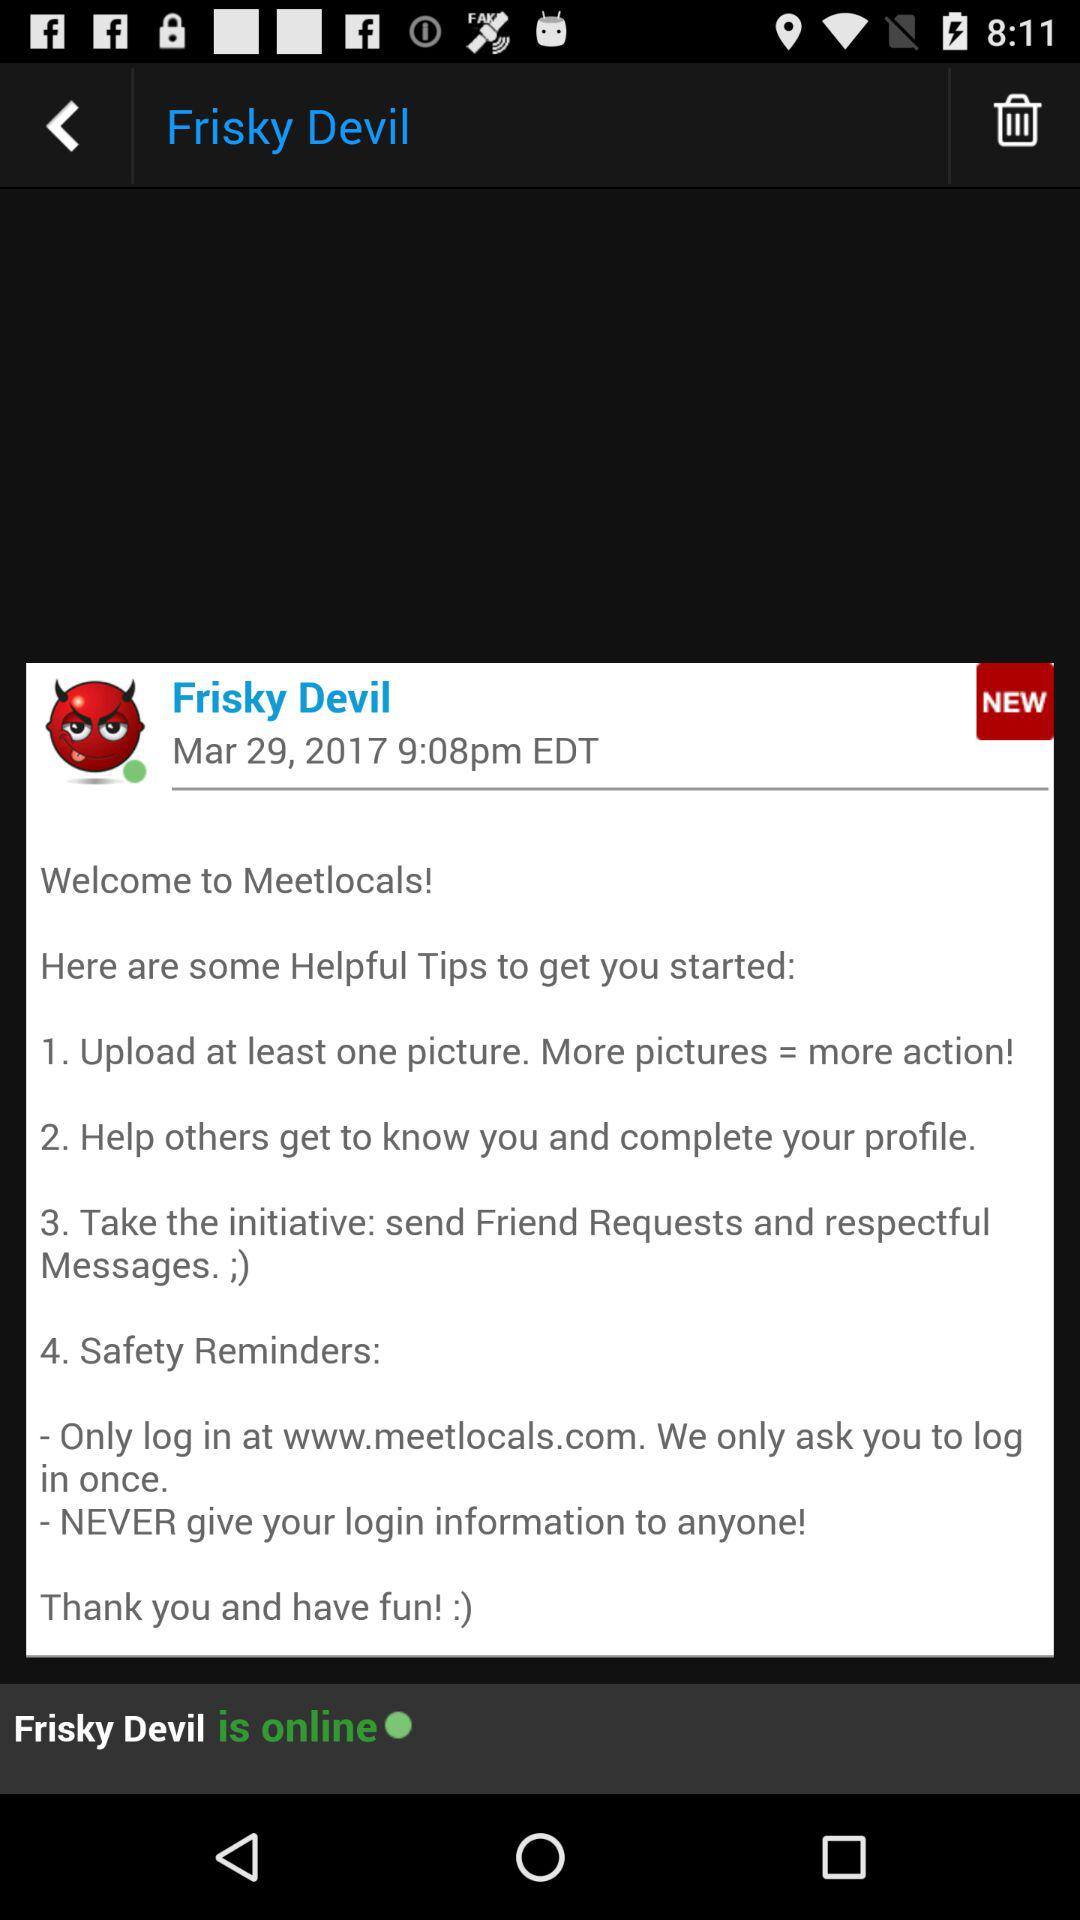What is the username? The username is "Frisky Devil". 